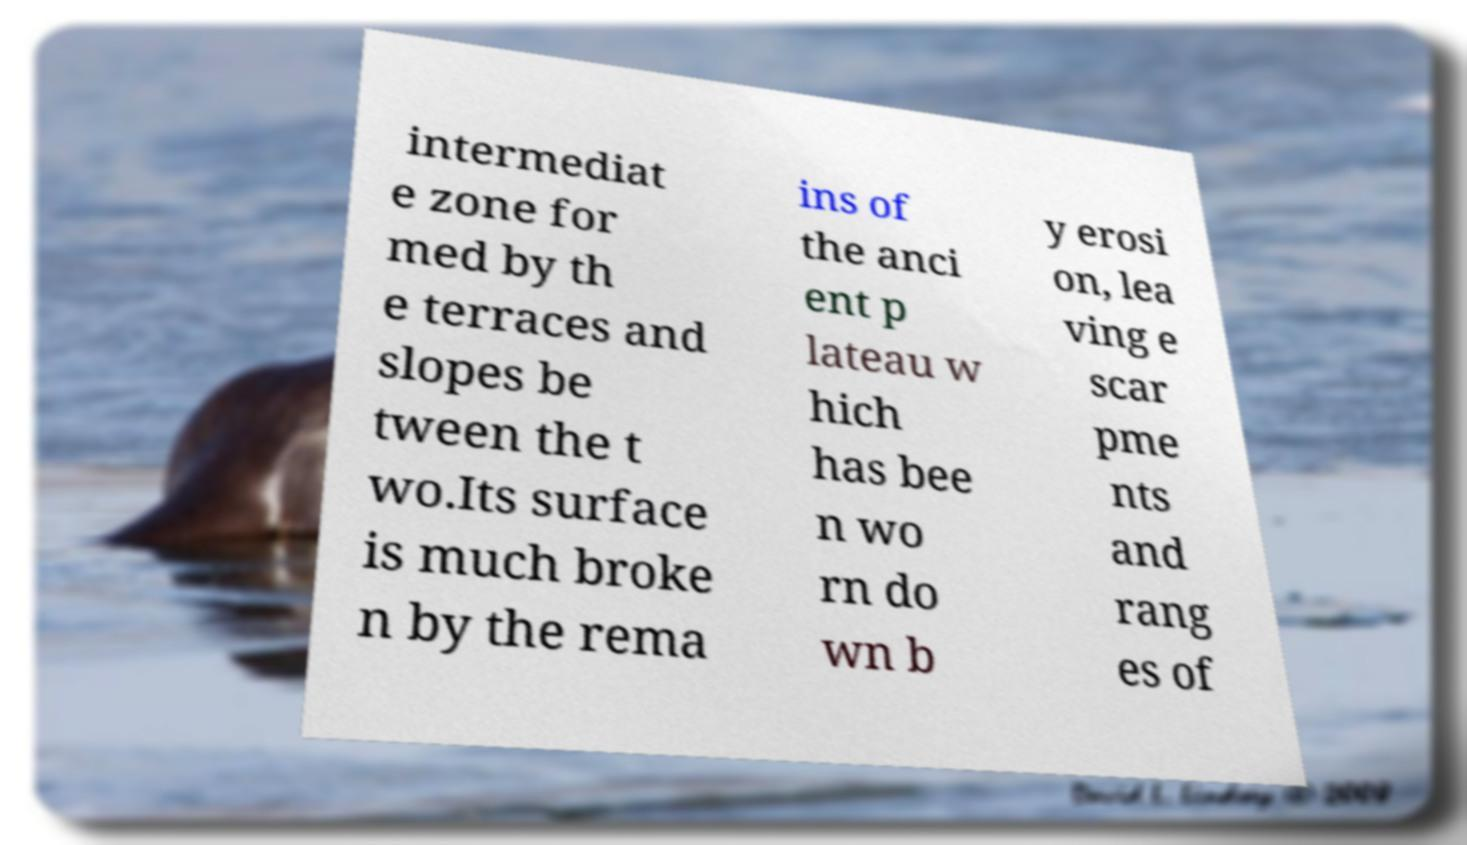Could you extract and type out the text from this image? intermediat e zone for med by th e terraces and slopes be tween the t wo.Its surface is much broke n by the rema ins of the anci ent p lateau w hich has bee n wo rn do wn b y erosi on, lea ving e scar pme nts and rang es of 